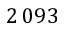<formula> <loc_0><loc_0><loc_500><loc_500>2 \, 0 9 3</formula> 